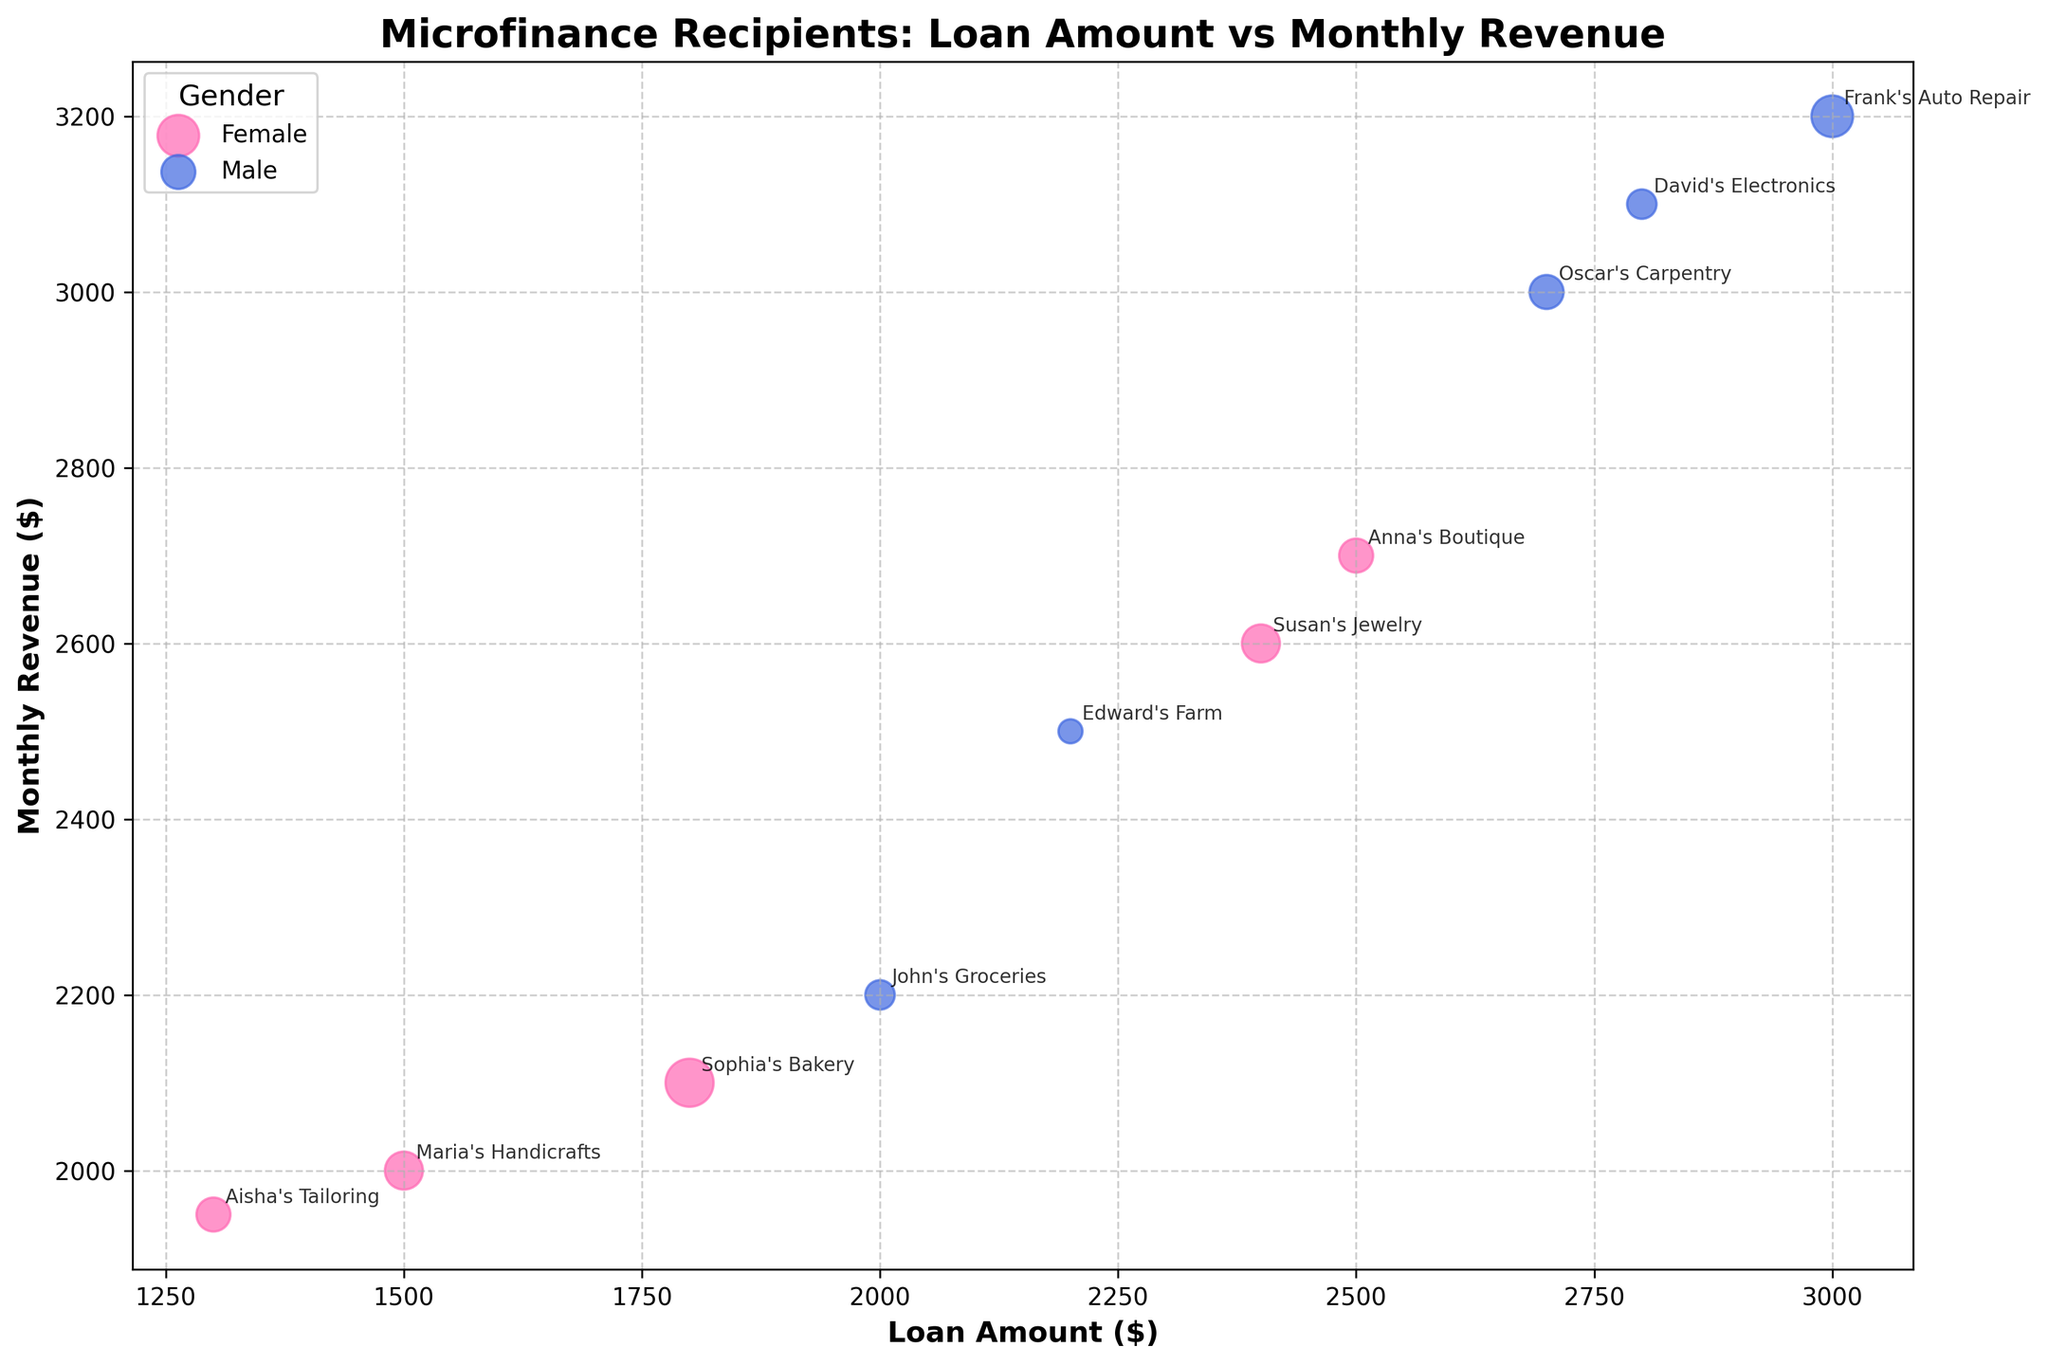What is the title of the figure? The title of the figure appears prominently at the top and usually summarizes the visualization's purpose.
Answer: Microfinance Recipients: Loan Amount vs Monthly Revenue How many data points are representing female microfinance recipients? We identify data points by looking at the bubbles, and their color represents the gender. Female recipients are represented by pink bubbles and count them.
Answer: 5 What is the range of loan amounts depicted on the x-axis? Observing the x-axis, the minimum and maximum points where the bubbles start and end give the range of the loan amounts.
Answer: $1300-$3000 Which business has the highest monthly revenue among female recipients? By cross-referencing the highest y-position of pink bubbles and the business names annotated nearby, we can identify the top performer's monthly revenue.
Answer: Anna’s Boutique What color represents male recipients in the figure? The color coding for male recipients is visible via the legend or by observation; male bubbles are consistently one color.
Answer: Blue Which male-owned business has the largest bubble, and what does it represent? The size of the bubbles correlates to the number of employees; hence, the largest blue bubble, with its business name label, indicates the business with the most employees.
Answer: Frank’s Auto Repair, 6 employees How does the loan amount relate to monthly revenue for female-owned businesses? By observing the pink bubbles' positions horizontally (loan amount) and vertically (monthly revenue), we can see if there's a pattern indicating a relationship between these two variables.
Answer: Generally, higher loan amounts correlate with higher monthly revenue What is the average profit margin of female-owned businesses shown in the chart? Referencing each annotated female-owned business, then summing up their profit margins and dividing by the number of businesses gives us the average value. Calculation: (0.15+0.20+0.18+0.17+0.22)/5 = 0.184
Answer: 0.184 Compare the highest monthly revenue between male and female recipients. Which gender has the higher value, and by how much? Find the highest monthly revenue for both genders by checking the uppermost points on the y-axis for pink and blue bubbles, then calculate the difference. Female: $2700 (Anna's Boutique), Male: $3200 (Frank's Auto Repair). Difference: $3200 - $2700 = $500
Answer: Male by $500 